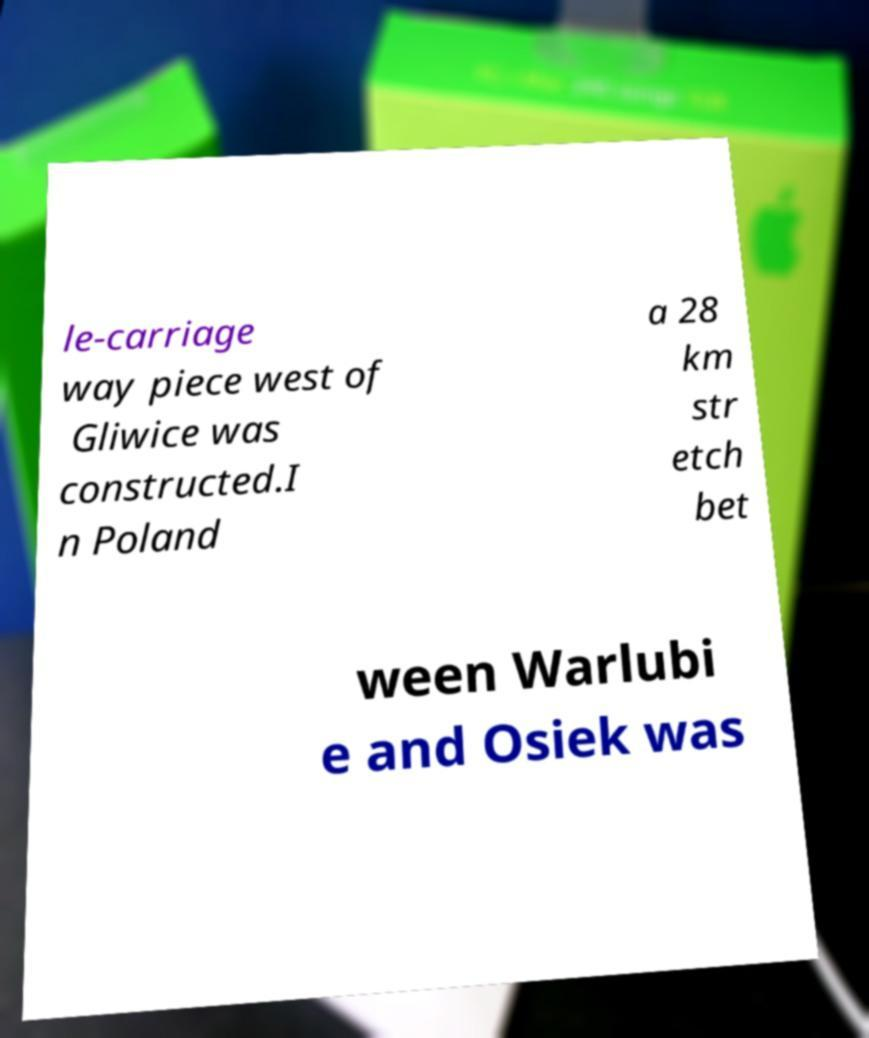Can you read and provide the text displayed in the image?This photo seems to have some interesting text. Can you extract and type it out for me? le-carriage way piece west of Gliwice was constructed.I n Poland a 28 km str etch bet ween Warlubi e and Osiek was 